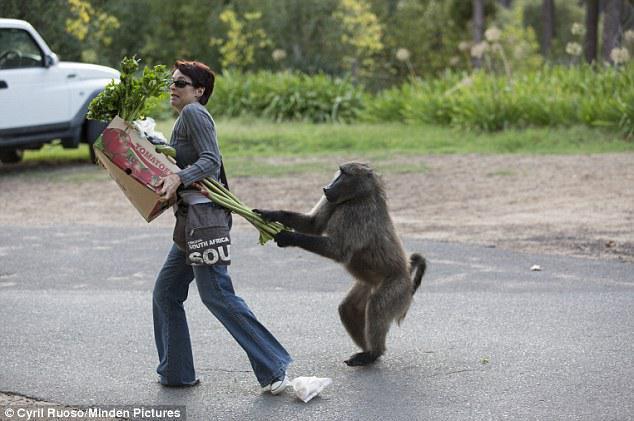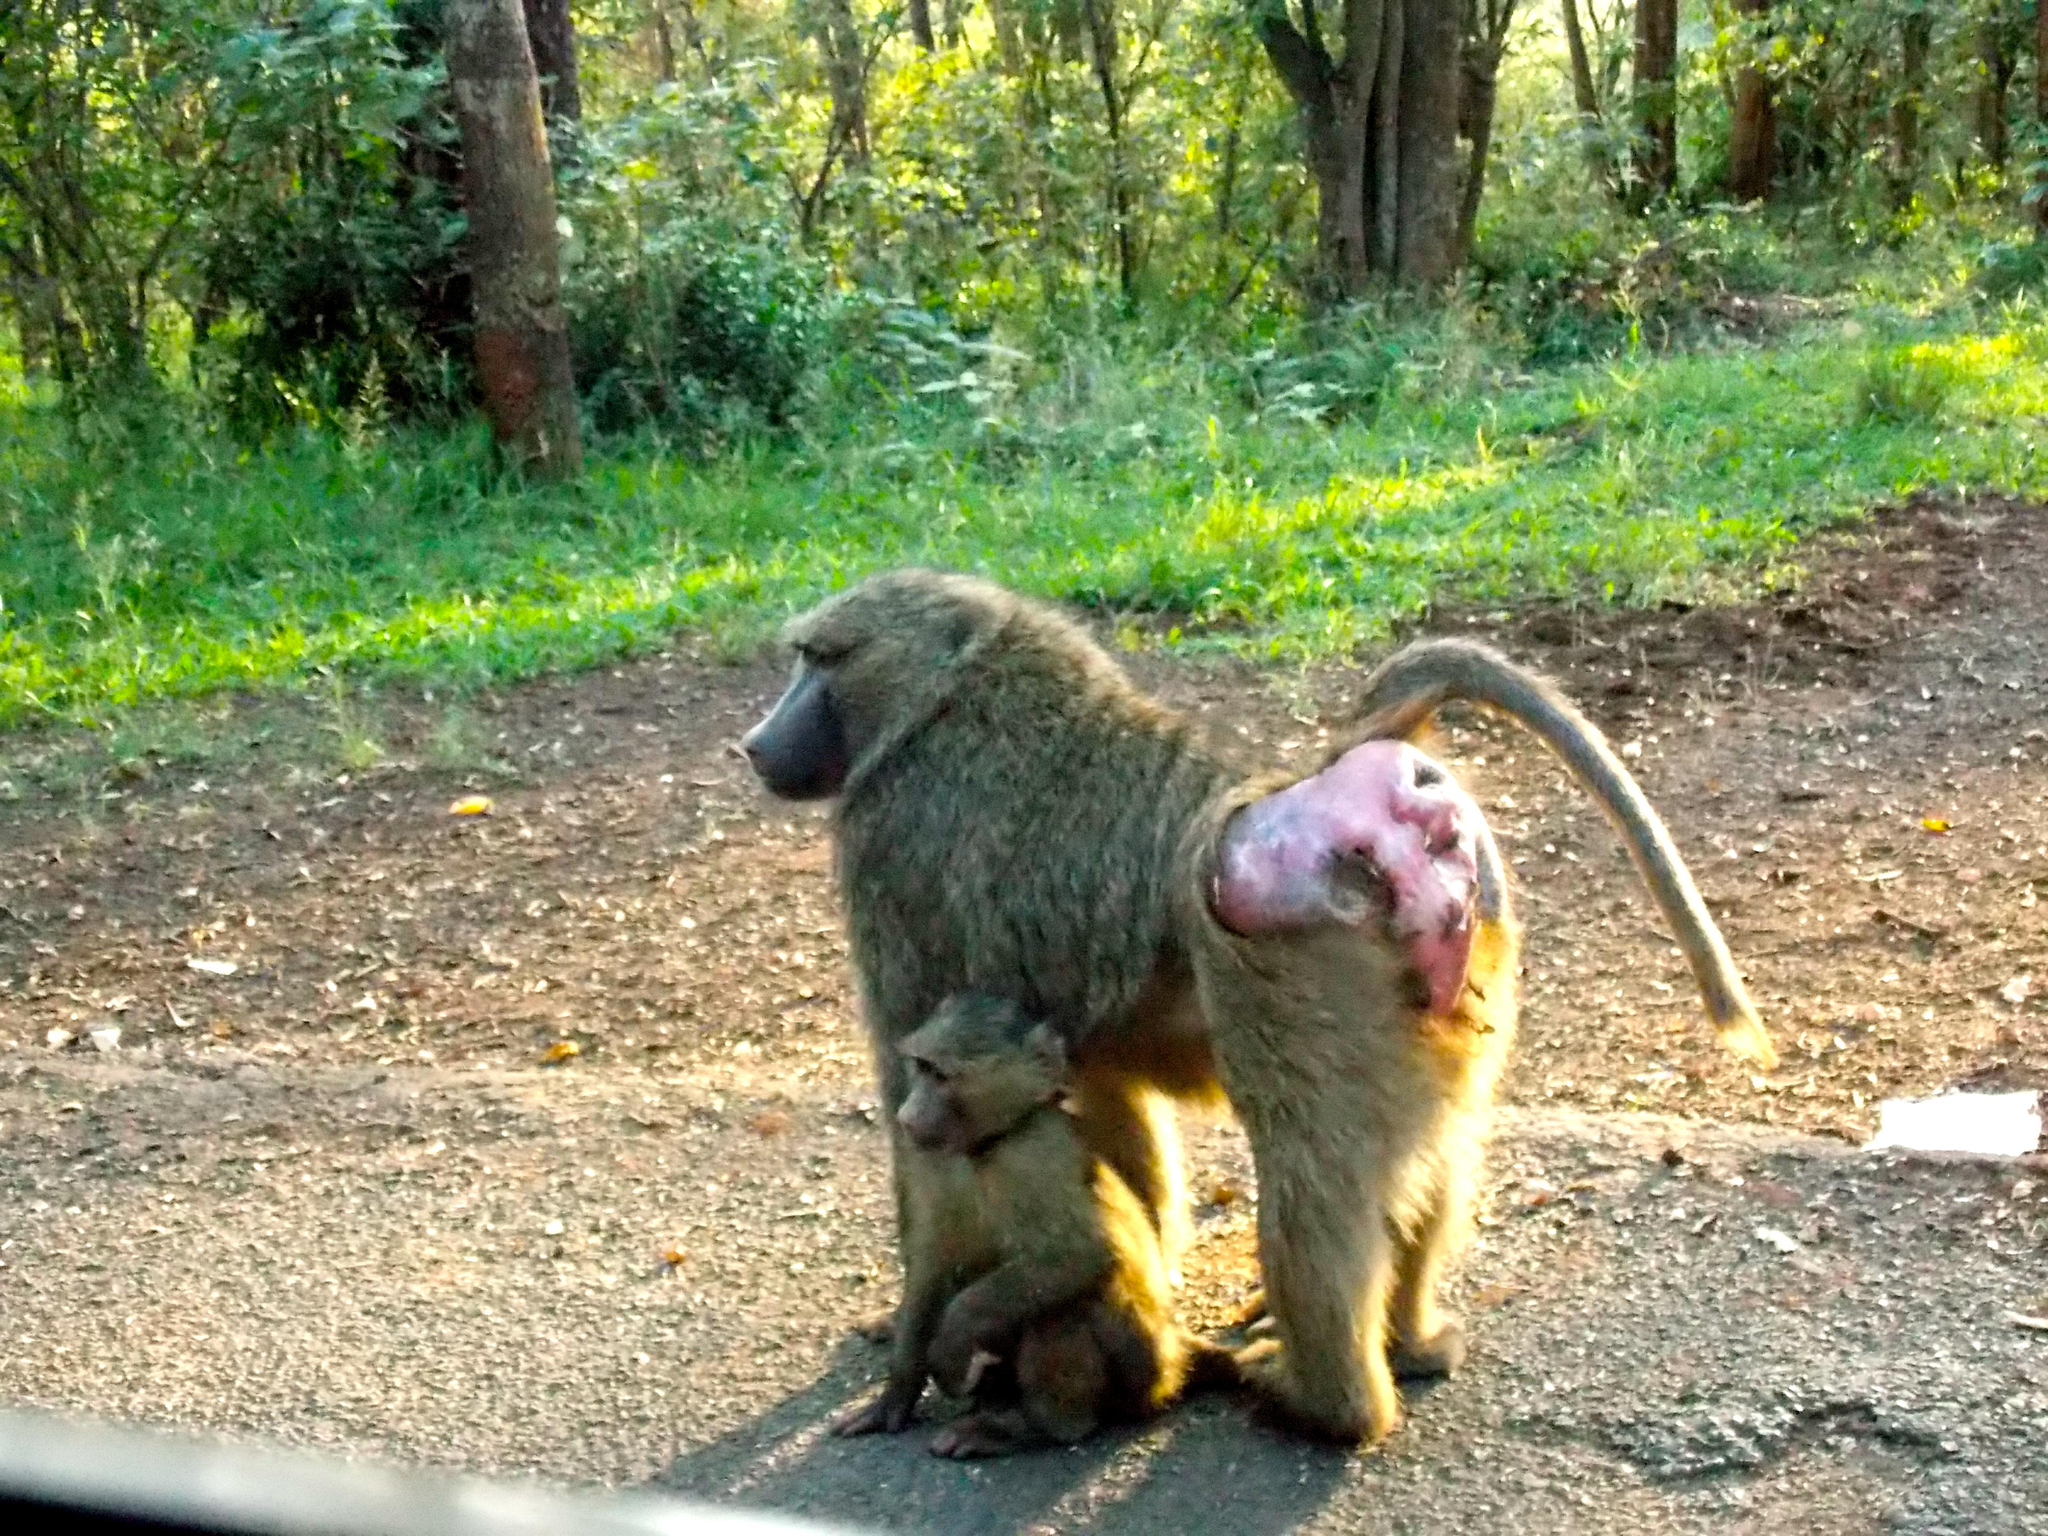The first image is the image on the left, the second image is the image on the right. Analyze the images presented: Is the assertion "There are monkeys on top of a vehicle's roof in at least one of the images." valid? Answer yes or no. No. The first image is the image on the left, the second image is the image on the right. Assess this claim about the two images: "The left image contains a woman carrying groceries.". Correct or not? Answer yes or no. Yes. 